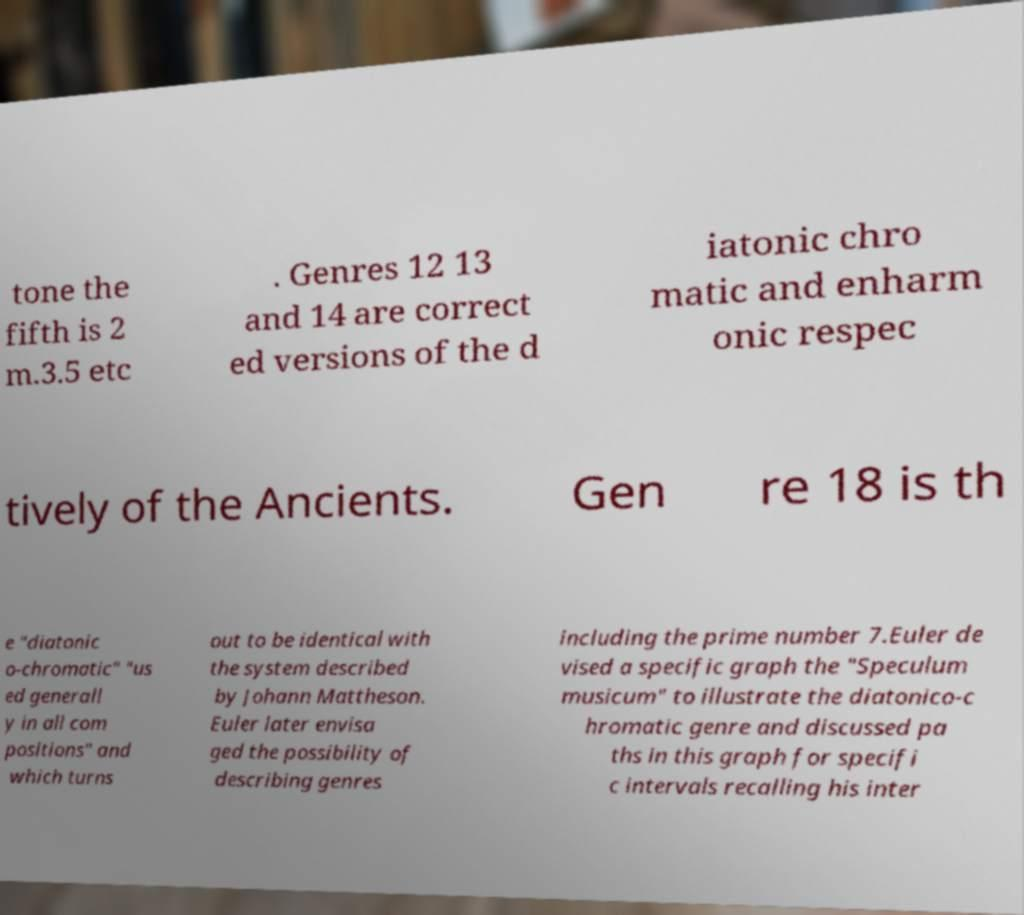Could you extract and type out the text from this image? tone the fifth is 2 m.3.5 etc . Genres 12 13 and 14 are correct ed versions of the d iatonic chro matic and enharm onic respec tively of the Ancients. Gen re 18 is th e "diatonic o-chromatic" "us ed generall y in all com positions" and which turns out to be identical with the system described by Johann Mattheson. Euler later envisa ged the possibility of describing genres including the prime number 7.Euler de vised a specific graph the "Speculum musicum" to illustrate the diatonico-c hromatic genre and discussed pa ths in this graph for specifi c intervals recalling his inter 